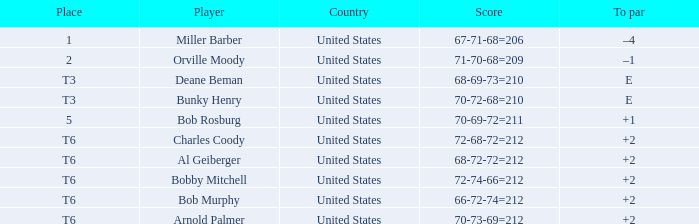What is the to par of player bunky henry? E. 